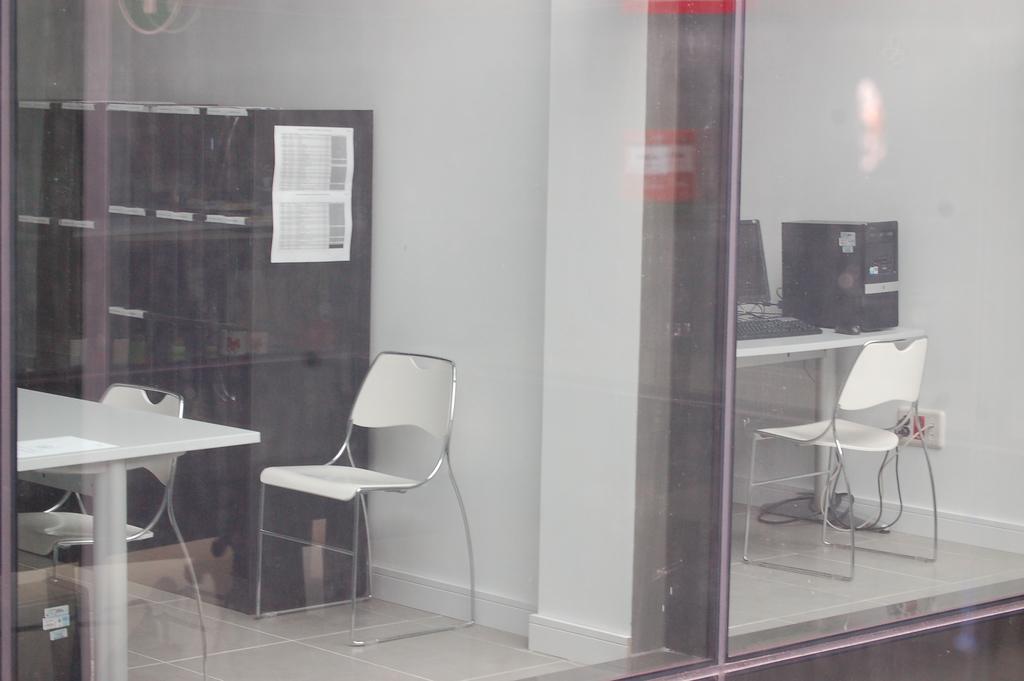In one or two sentences, can you explain what this image depicts? In this image we can see chairs, a table and there is a computer placed on the table and there is a wardrobe. 